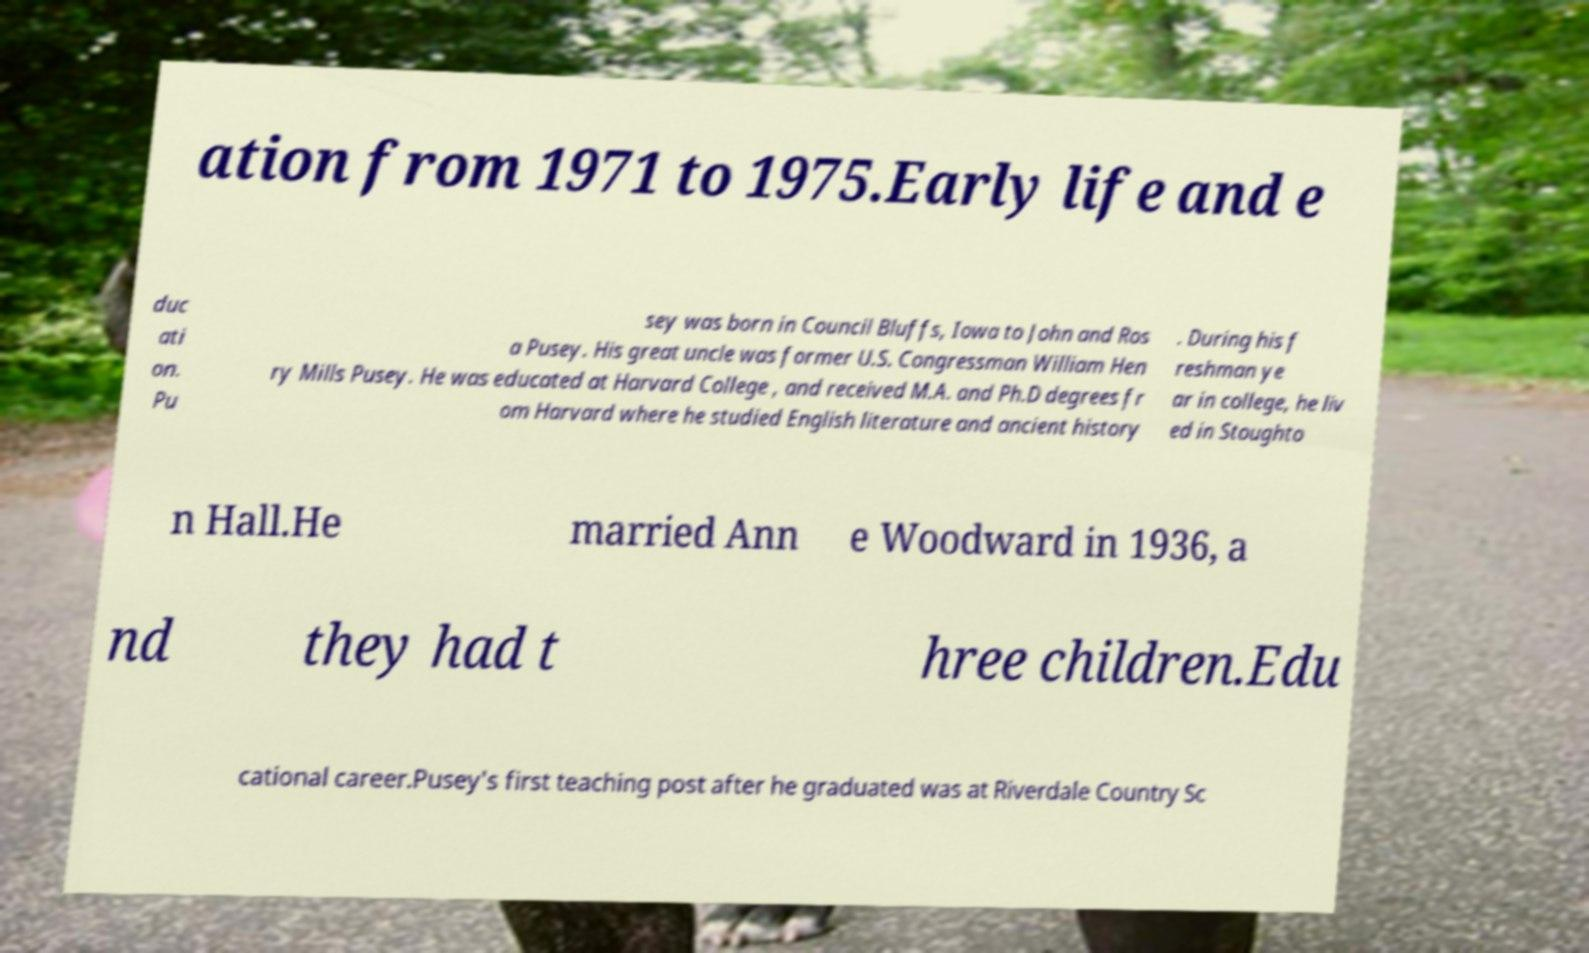Could you assist in decoding the text presented in this image and type it out clearly? ation from 1971 to 1975.Early life and e duc ati on. Pu sey was born in Council Bluffs, Iowa to John and Ros a Pusey. His great uncle was former U.S. Congressman William Hen ry Mills Pusey. He was educated at Harvard College , and received M.A. and Ph.D degrees fr om Harvard where he studied English literature and ancient history . During his f reshman ye ar in college, he liv ed in Stoughto n Hall.He married Ann e Woodward in 1936, a nd they had t hree children.Edu cational career.Pusey's first teaching post after he graduated was at Riverdale Country Sc 